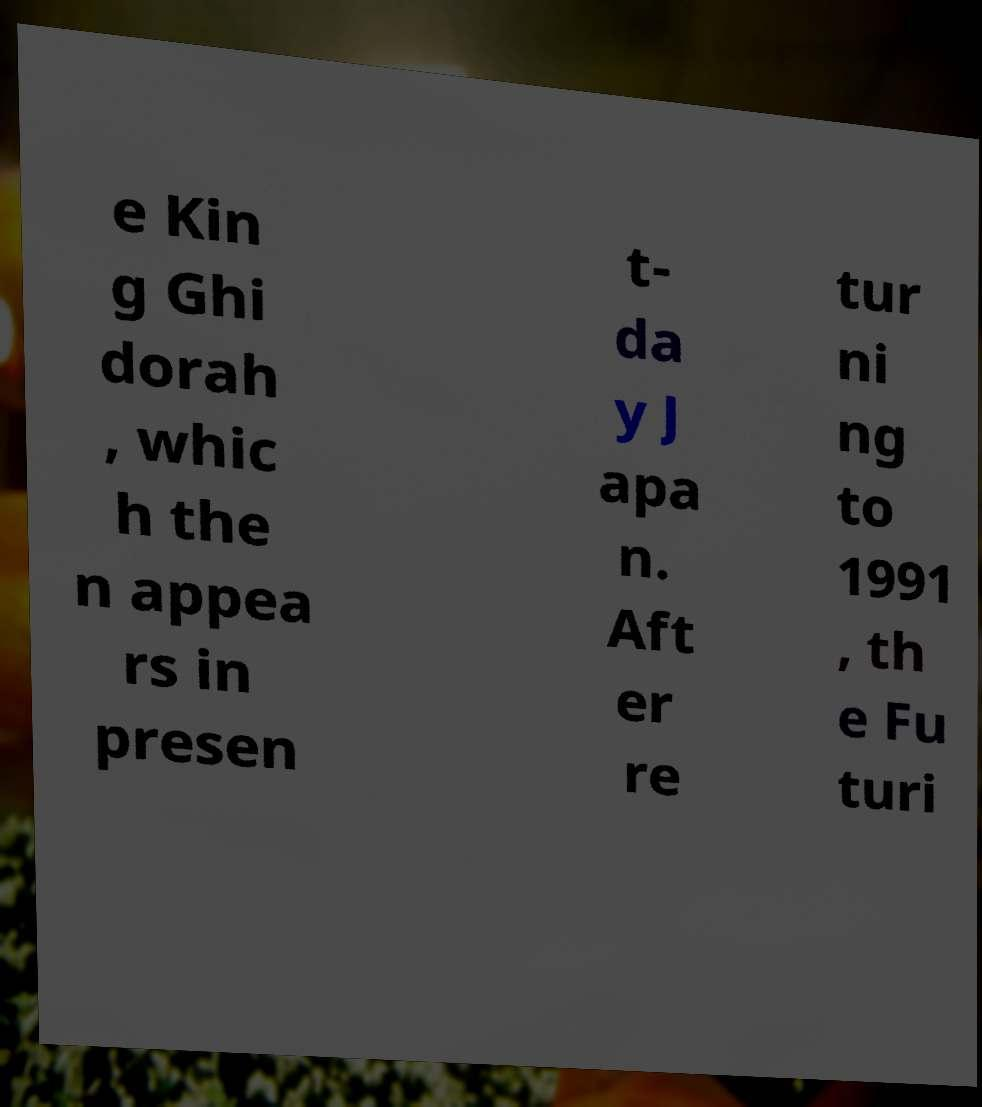Can you read and provide the text displayed in the image?This photo seems to have some interesting text. Can you extract and type it out for me? e Kin g Ghi dorah , whic h the n appea rs in presen t- da y J apa n. Aft er re tur ni ng to 1991 , th e Fu turi 